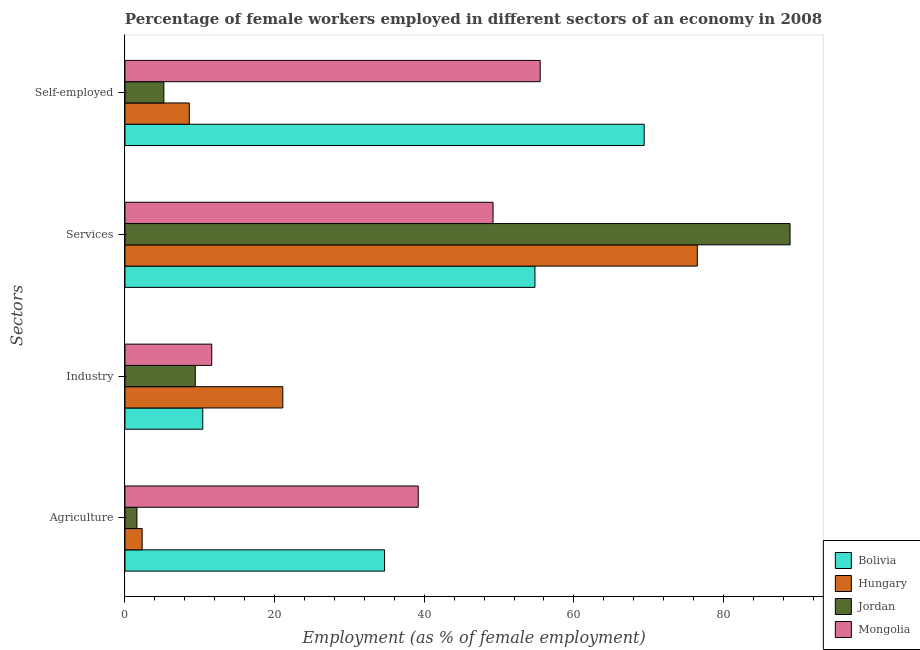How many different coloured bars are there?
Keep it short and to the point. 4. Are the number of bars on each tick of the Y-axis equal?
Provide a short and direct response. Yes. What is the label of the 4th group of bars from the top?
Your answer should be compact. Agriculture. What is the percentage of female workers in agriculture in Jordan?
Give a very brief answer. 1.6. Across all countries, what is the maximum percentage of female workers in industry?
Keep it short and to the point. 21.1. Across all countries, what is the minimum percentage of female workers in industry?
Offer a very short reply. 9.4. In which country was the percentage of female workers in services maximum?
Your response must be concise. Jordan. In which country was the percentage of female workers in services minimum?
Provide a short and direct response. Mongolia. What is the total percentage of female workers in industry in the graph?
Your response must be concise. 52.5. What is the difference between the percentage of female workers in agriculture in Hungary and that in Mongolia?
Make the answer very short. -36.9. What is the difference between the percentage of self employed female workers in Jordan and the percentage of female workers in agriculture in Bolivia?
Provide a short and direct response. -29.5. What is the average percentage of female workers in agriculture per country?
Your answer should be very brief. 19.45. What is the difference between the percentage of female workers in industry and percentage of female workers in services in Jordan?
Provide a short and direct response. -79.5. What is the ratio of the percentage of female workers in agriculture in Bolivia to that in Mongolia?
Your answer should be very brief. 0.89. Is the percentage of female workers in services in Mongolia less than that in Hungary?
Your answer should be very brief. Yes. What is the difference between the highest and the second highest percentage of female workers in industry?
Give a very brief answer. 9.5. What is the difference between the highest and the lowest percentage of female workers in agriculture?
Provide a succinct answer. 37.6. Is it the case that in every country, the sum of the percentage of female workers in services and percentage of self employed female workers is greater than the sum of percentage of female workers in industry and percentage of female workers in agriculture?
Offer a very short reply. Yes. What does the 1st bar from the bottom in Industry represents?
Give a very brief answer. Bolivia. Is it the case that in every country, the sum of the percentage of female workers in agriculture and percentage of female workers in industry is greater than the percentage of female workers in services?
Keep it short and to the point. No. Are all the bars in the graph horizontal?
Provide a succinct answer. Yes. How many countries are there in the graph?
Make the answer very short. 4. Does the graph contain grids?
Your answer should be compact. No. What is the title of the graph?
Offer a terse response. Percentage of female workers employed in different sectors of an economy in 2008. Does "Panama" appear as one of the legend labels in the graph?
Your answer should be very brief. No. What is the label or title of the X-axis?
Offer a very short reply. Employment (as % of female employment). What is the label or title of the Y-axis?
Give a very brief answer. Sectors. What is the Employment (as % of female employment) in Bolivia in Agriculture?
Offer a terse response. 34.7. What is the Employment (as % of female employment) in Hungary in Agriculture?
Keep it short and to the point. 2.3. What is the Employment (as % of female employment) in Jordan in Agriculture?
Your response must be concise. 1.6. What is the Employment (as % of female employment) of Mongolia in Agriculture?
Your response must be concise. 39.2. What is the Employment (as % of female employment) of Bolivia in Industry?
Provide a succinct answer. 10.4. What is the Employment (as % of female employment) of Hungary in Industry?
Provide a short and direct response. 21.1. What is the Employment (as % of female employment) of Jordan in Industry?
Provide a succinct answer. 9.4. What is the Employment (as % of female employment) of Mongolia in Industry?
Make the answer very short. 11.6. What is the Employment (as % of female employment) of Bolivia in Services?
Your response must be concise. 54.8. What is the Employment (as % of female employment) in Hungary in Services?
Offer a very short reply. 76.5. What is the Employment (as % of female employment) in Jordan in Services?
Make the answer very short. 88.9. What is the Employment (as % of female employment) of Mongolia in Services?
Give a very brief answer. 49.2. What is the Employment (as % of female employment) of Bolivia in Self-employed?
Your response must be concise. 69.4. What is the Employment (as % of female employment) in Hungary in Self-employed?
Provide a succinct answer. 8.6. What is the Employment (as % of female employment) in Jordan in Self-employed?
Keep it short and to the point. 5.2. What is the Employment (as % of female employment) in Mongolia in Self-employed?
Offer a terse response. 55.5. Across all Sectors, what is the maximum Employment (as % of female employment) in Bolivia?
Give a very brief answer. 69.4. Across all Sectors, what is the maximum Employment (as % of female employment) in Hungary?
Keep it short and to the point. 76.5. Across all Sectors, what is the maximum Employment (as % of female employment) in Jordan?
Ensure brevity in your answer.  88.9. Across all Sectors, what is the maximum Employment (as % of female employment) in Mongolia?
Offer a terse response. 55.5. Across all Sectors, what is the minimum Employment (as % of female employment) in Bolivia?
Keep it short and to the point. 10.4. Across all Sectors, what is the minimum Employment (as % of female employment) of Hungary?
Ensure brevity in your answer.  2.3. Across all Sectors, what is the minimum Employment (as % of female employment) in Jordan?
Keep it short and to the point. 1.6. Across all Sectors, what is the minimum Employment (as % of female employment) of Mongolia?
Provide a succinct answer. 11.6. What is the total Employment (as % of female employment) in Bolivia in the graph?
Your response must be concise. 169.3. What is the total Employment (as % of female employment) of Hungary in the graph?
Ensure brevity in your answer.  108.5. What is the total Employment (as % of female employment) of Jordan in the graph?
Your answer should be compact. 105.1. What is the total Employment (as % of female employment) in Mongolia in the graph?
Provide a short and direct response. 155.5. What is the difference between the Employment (as % of female employment) of Bolivia in Agriculture and that in Industry?
Your answer should be compact. 24.3. What is the difference between the Employment (as % of female employment) in Hungary in Agriculture and that in Industry?
Your answer should be very brief. -18.8. What is the difference between the Employment (as % of female employment) of Jordan in Agriculture and that in Industry?
Provide a short and direct response. -7.8. What is the difference between the Employment (as % of female employment) in Mongolia in Agriculture and that in Industry?
Offer a very short reply. 27.6. What is the difference between the Employment (as % of female employment) of Bolivia in Agriculture and that in Services?
Provide a short and direct response. -20.1. What is the difference between the Employment (as % of female employment) in Hungary in Agriculture and that in Services?
Offer a terse response. -74.2. What is the difference between the Employment (as % of female employment) in Jordan in Agriculture and that in Services?
Provide a short and direct response. -87.3. What is the difference between the Employment (as % of female employment) in Bolivia in Agriculture and that in Self-employed?
Offer a very short reply. -34.7. What is the difference between the Employment (as % of female employment) of Jordan in Agriculture and that in Self-employed?
Make the answer very short. -3.6. What is the difference between the Employment (as % of female employment) in Mongolia in Agriculture and that in Self-employed?
Your answer should be compact. -16.3. What is the difference between the Employment (as % of female employment) of Bolivia in Industry and that in Services?
Your response must be concise. -44.4. What is the difference between the Employment (as % of female employment) of Hungary in Industry and that in Services?
Make the answer very short. -55.4. What is the difference between the Employment (as % of female employment) of Jordan in Industry and that in Services?
Give a very brief answer. -79.5. What is the difference between the Employment (as % of female employment) of Mongolia in Industry and that in Services?
Offer a very short reply. -37.6. What is the difference between the Employment (as % of female employment) in Bolivia in Industry and that in Self-employed?
Keep it short and to the point. -59. What is the difference between the Employment (as % of female employment) of Hungary in Industry and that in Self-employed?
Keep it short and to the point. 12.5. What is the difference between the Employment (as % of female employment) in Jordan in Industry and that in Self-employed?
Make the answer very short. 4.2. What is the difference between the Employment (as % of female employment) in Mongolia in Industry and that in Self-employed?
Keep it short and to the point. -43.9. What is the difference between the Employment (as % of female employment) of Bolivia in Services and that in Self-employed?
Provide a succinct answer. -14.6. What is the difference between the Employment (as % of female employment) in Hungary in Services and that in Self-employed?
Your answer should be very brief. 67.9. What is the difference between the Employment (as % of female employment) of Jordan in Services and that in Self-employed?
Ensure brevity in your answer.  83.7. What is the difference between the Employment (as % of female employment) in Mongolia in Services and that in Self-employed?
Your response must be concise. -6.3. What is the difference between the Employment (as % of female employment) in Bolivia in Agriculture and the Employment (as % of female employment) in Jordan in Industry?
Your answer should be very brief. 25.3. What is the difference between the Employment (as % of female employment) in Bolivia in Agriculture and the Employment (as % of female employment) in Mongolia in Industry?
Give a very brief answer. 23.1. What is the difference between the Employment (as % of female employment) in Bolivia in Agriculture and the Employment (as % of female employment) in Hungary in Services?
Offer a terse response. -41.8. What is the difference between the Employment (as % of female employment) in Bolivia in Agriculture and the Employment (as % of female employment) in Jordan in Services?
Provide a short and direct response. -54.2. What is the difference between the Employment (as % of female employment) in Bolivia in Agriculture and the Employment (as % of female employment) in Mongolia in Services?
Your answer should be compact. -14.5. What is the difference between the Employment (as % of female employment) of Hungary in Agriculture and the Employment (as % of female employment) of Jordan in Services?
Make the answer very short. -86.6. What is the difference between the Employment (as % of female employment) in Hungary in Agriculture and the Employment (as % of female employment) in Mongolia in Services?
Offer a terse response. -46.9. What is the difference between the Employment (as % of female employment) of Jordan in Agriculture and the Employment (as % of female employment) of Mongolia in Services?
Your answer should be compact. -47.6. What is the difference between the Employment (as % of female employment) in Bolivia in Agriculture and the Employment (as % of female employment) in Hungary in Self-employed?
Ensure brevity in your answer.  26.1. What is the difference between the Employment (as % of female employment) of Bolivia in Agriculture and the Employment (as % of female employment) of Jordan in Self-employed?
Keep it short and to the point. 29.5. What is the difference between the Employment (as % of female employment) in Bolivia in Agriculture and the Employment (as % of female employment) in Mongolia in Self-employed?
Keep it short and to the point. -20.8. What is the difference between the Employment (as % of female employment) of Hungary in Agriculture and the Employment (as % of female employment) of Mongolia in Self-employed?
Provide a short and direct response. -53.2. What is the difference between the Employment (as % of female employment) of Jordan in Agriculture and the Employment (as % of female employment) of Mongolia in Self-employed?
Your response must be concise. -53.9. What is the difference between the Employment (as % of female employment) in Bolivia in Industry and the Employment (as % of female employment) in Hungary in Services?
Your answer should be very brief. -66.1. What is the difference between the Employment (as % of female employment) in Bolivia in Industry and the Employment (as % of female employment) in Jordan in Services?
Offer a very short reply. -78.5. What is the difference between the Employment (as % of female employment) of Bolivia in Industry and the Employment (as % of female employment) of Mongolia in Services?
Keep it short and to the point. -38.8. What is the difference between the Employment (as % of female employment) in Hungary in Industry and the Employment (as % of female employment) in Jordan in Services?
Offer a terse response. -67.8. What is the difference between the Employment (as % of female employment) in Hungary in Industry and the Employment (as % of female employment) in Mongolia in Services?
Provide a succinct answer. -28.1. What is the difference between the Employment (as % of female employment) in Jordan in Industry and the Employment (as % of female employment) in Mongolia in Services?
Ensure brevity in your answer.  -39.8. What is the difference between the Employment (as % of female employment) in Bolivia in Industry and the Employment (as % of female employment) in Mongolia in Self-employed?
Make the answer very short. -45.1. What is the difference between the Employment (as % of female employment) in Hungary in Industry and the Employment (as % of female employment) in Jordan in Self-employed?
Provide a succinct answer. 15.9. What is the difference between the Employment (as % of female employment) in Hungary in Industry and the Employment (as % of female employment) in Mongolia in Self-employed?
Your answer should be very brief. -34.4. What is the difference between the Employment (as % of female employment) of Jordan in Industry and the Employment (as % of female employment) of Mongolia in Self-employed?
Provide a succinct answer. -46.1. What is the difference between the Employment (as % of female employment) in Bolivia in Services and the Employment (as % of female employment) in Hungary in Self-employed?
Ensure brevity in your answer.  46.2. What is the difference between the Employment (as % of female employment) in Bolivia in Services and the Employment (as % of female employment) in Jordan in Self-employed?
Provide a succinct answer. 49.6. What is the difference between the Employment (as % of female employment) of Hungary in Services and the Employment (as % of female employment) of Jordan in Self-employed?
Provide a short and direct response. 71.3. What is the difference between the Employment (as % of female employment) in Hungary in Services and the Employment (as % of female employment) in Mongolia in Self-employed?
Provide a succinct answer. 21. What is the difference between the Employment (as % of female employment) of Jordan in Services and the Employment (as % of female employment) of Mongolia in Self-employed?
Ensure brevity in your answer.  33.4. What is the average Employment (as % of female employment) in Bolivia per Sectors?
Offer a terse response. 42.33. What is the average Employment (as % of female employment) of Hungary per Sectors?
Your answer should be compact. 27.12. What is the average Employment (as % of female employment) of Jordan per Sectors?
Give a very brief answer. 26.27. What is the average Employment (as % of female employment) of Mongolia per Sectors?
Offer a terse response. 38.88. What is the difference between the Employment (as % of female employment) of Bolivia and Employment (as % of female employment) of Hungary in Agriculture?
Keep it short and to the point. 32.4. What is the difference between the Employment (as % of female employment) in Bolivia and Employment (as % of female employment) in Jordan in Agriculture?
Provide a succinct answer. 33.1. What is the difference between the Employment (as % of female employment) of Hungary and Employment (as % of female employment) of Mongolia in Agriculture?
Your answer should be compact. -36.9. What is the difference between the Employment (as % of female employment) in Jordan and Employment (as % of female employment) in Mongolia in Agriculture?
Your answer should be compact. -37.6. What is the difference between the Employment (as % of female employment) in Bolivia and Employment (as % of female employment) in Hungary in Industry?
Keep it short and to the point. -10.7. What is the difference between the Employment (as % of female employment) in Hungary and Employment (as % of female employment) in Mongolia in Industry?
Your response must be concise. 9.5. What is the difference between the Employment (as % of female employment) in Bolivia and Employment (as % of female employment) in Hungary in Services?
Your answer should be very brief. -21.7. What is the difference between the Employment (as % of female employment) in Bolivia and Employment (as % of female employment) in Jordan in Services?
Offer a terse response. -34.1. What is the difference between the Employment (as % of female employment) in Bolivia and Employment (as % of female employment) in Mongolia in Services?
Provide a short and direct response. 5.6. What is the difference between the Employment (as % of female employment) of Hungary and Employment (as % of female employment) of Jordan in Services?
Keep it short and to the point. -12.4. What is the difference between the Employment (as % of female employment) of Hungary and Employment (as % of female employment) of Mongolia in Services?
Your answer should be compact. 27.3. What is the difference between the Employment (as % of female employment) of Jordan and Employment (as % of female employment) of Mongolia in Services?
Keep it short and to the point. 39.7. What is the difference between the Employment (as % of female employment) in Bolivia and Employment (as % of female employment) in Hungary in Self-employed?
Make the answer very short. 60.8. What is the difference between the Employment (as % of female employment) of Bolivia and Employment (as % of female employment) of Jordan in Self-employed?
Your answer should be very brief. 64.2. What is the difference between the Employment (as % of female employment) in Hungary and Employment (as % of female employment) in Mongolia in Self-employed?
Your answer should be compact. -46.9. What is the difference between the Employment (as % of female employment) in Jordan and Employment (as % of female employment) in Mongolia in Self-employed?
Ensure brevity in your answer.  -50.3. What is the ratio of the Employment (as % of female employment) of Bolivia in Agriculture to that in Industry?
Your response must be concise. 3.34. What is the ratio of the Employment (as % of female employment) in Hungary in Agriculture to that in Industry?
Your answer should be compact. 0.11. What is the ratio of the Employment (as % of female employment) in Jordan in Agriculture to that in Industry?
Provide a succinct answer. 0.17. What is the ratio of the Employment (as % of female employment) in Mongolia in Agriculture to that in Industry?
Provide a short and direct response. 3.38. What is the ratio of the Employment (as % of female employment) in Bolivia in Agriculture to that in Services?
Provide a succinct answer. 0.63. What is the ratio of the Employment (as % of female employment) in Hungary in Agriculture to that in Services?
Keep it short and to the point. 0.03. What is the ratio of the Employment (as % of female employment) of Jordan in Agriculture to that in Services?
Offer a very short reply. 0.02. What is the ratio of the Employment (as % of female employment) of Mongolia in Agriculture to that in Services?
Ensure brevity in your answer.  0.8. What is the ratio of the Employment (as % of female employment) in Bolivia in Agriculture to that in Self-employed?
Offer a very short reply. 0.5. What is the ratio of the Employment (as % of female employment) of Hungary in Agriculture to that in Self-employed?
Your answer should be compact. 0.27. What is the ratio of the Employment (as % of female employment) of Jordan in Agriculture to that in Self-employed?
Provide a short and direct response. 0.31. What is the ratio of the Employment (as % of female employment) of Mongolia in Agriculture to that in Self-employed?
Your answer should be compact. 0.71. What is the ratio of the Employment (as % of female employment) of Bolivia in Industry to that in Services?
Ensure brevity in your answer.  0.19. What is the ratio of the Employment (as % of female employment) in Hungary in Industry to that in Services?
Provide a short and direct response. 0.28. What is the ratio of the Employment (as % of female employment) in Jordan in Industry to that in Services?
Provide a succinct answer. 0.11. What is the ratio of the Employment (as % of female employment) of Mongolia in Industry to that in Services?
Offer a very short reply. 0.24. What is the ratio of the Employment (as % of female employment) of Bolivia in Industry to that in Self-employed?
Provide a succinct answer. 0.15. What is the ratio of the Employment (as % of female employment) in Hungary in Industry to that in Self-employed?
Give a very brief answer. 2.45. What is the ratio of the Employment (as % of female employment) in Jordan in Industry to that in Self-employed?
Offer a terse response. 1.81. What is the ratio of the Employment (as % of female employment) of Mongolia in Industry to that in Self-employed?
Provide a succinct answer. 0.21. What is the ratio of the Employment (as % of female employment) of Bolivia in Services to that in Self-employed?
Offer a very short reply. 0.79. What is the ratio of the Employment (as % of female employment) of Hungary in Services to that in Self-employed?
Make the answer very short. 8.9. What is the ratio of the Employment (as % of female employment) of Jordan in Services to that in Self-employed?
Give a very brief answer. 17.1. What is the ratio of the Employment (as % of female employment) in Mongolia in Services to that in Self-employed?
Offer a very short reply. 0.89. What is the difference between the highest and the second highest Employment (as % of female employment) in Hungary?
Keep it short and to the point. 55.4. What is the difference between the highest and the second highest Employment (as % of female employment) of Jordan?
Keep it short and to the point. 79.5. What is the difference between the highest and the lowest Employment (as % of female employment) in Bolivia?
Provide a short and direct response. 59. What is the difference between the highest and the lowest Employment (as % of female employment) in Hungary?
Make the answer very short. 74.2. What is the difference between the highest and the lowest Employment (as % of female employment) in Jordan?
Keep it short and to the point. 87.3. What is the difference between the highest and the lowest Employment (as % of female employment) of Mongolia?
Ensure brevity in your answer.  43.9. 